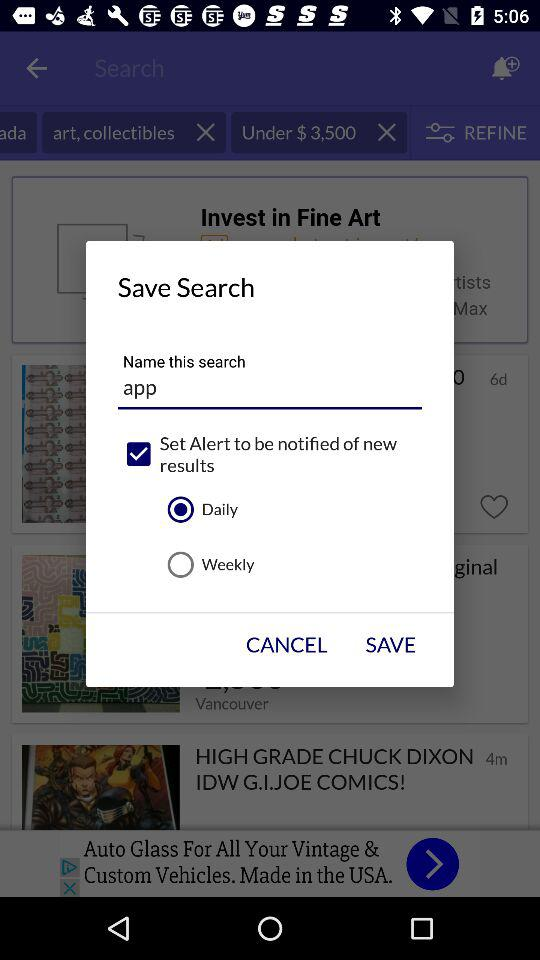How many baby items are there? There are 268,933 baby items. 